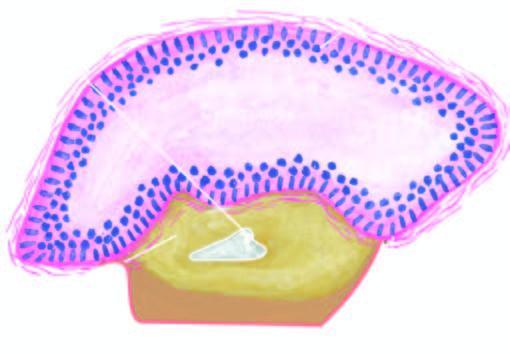re collections of histiocytes conspicuously absent?
Answer the question using a single word or phrase. No 